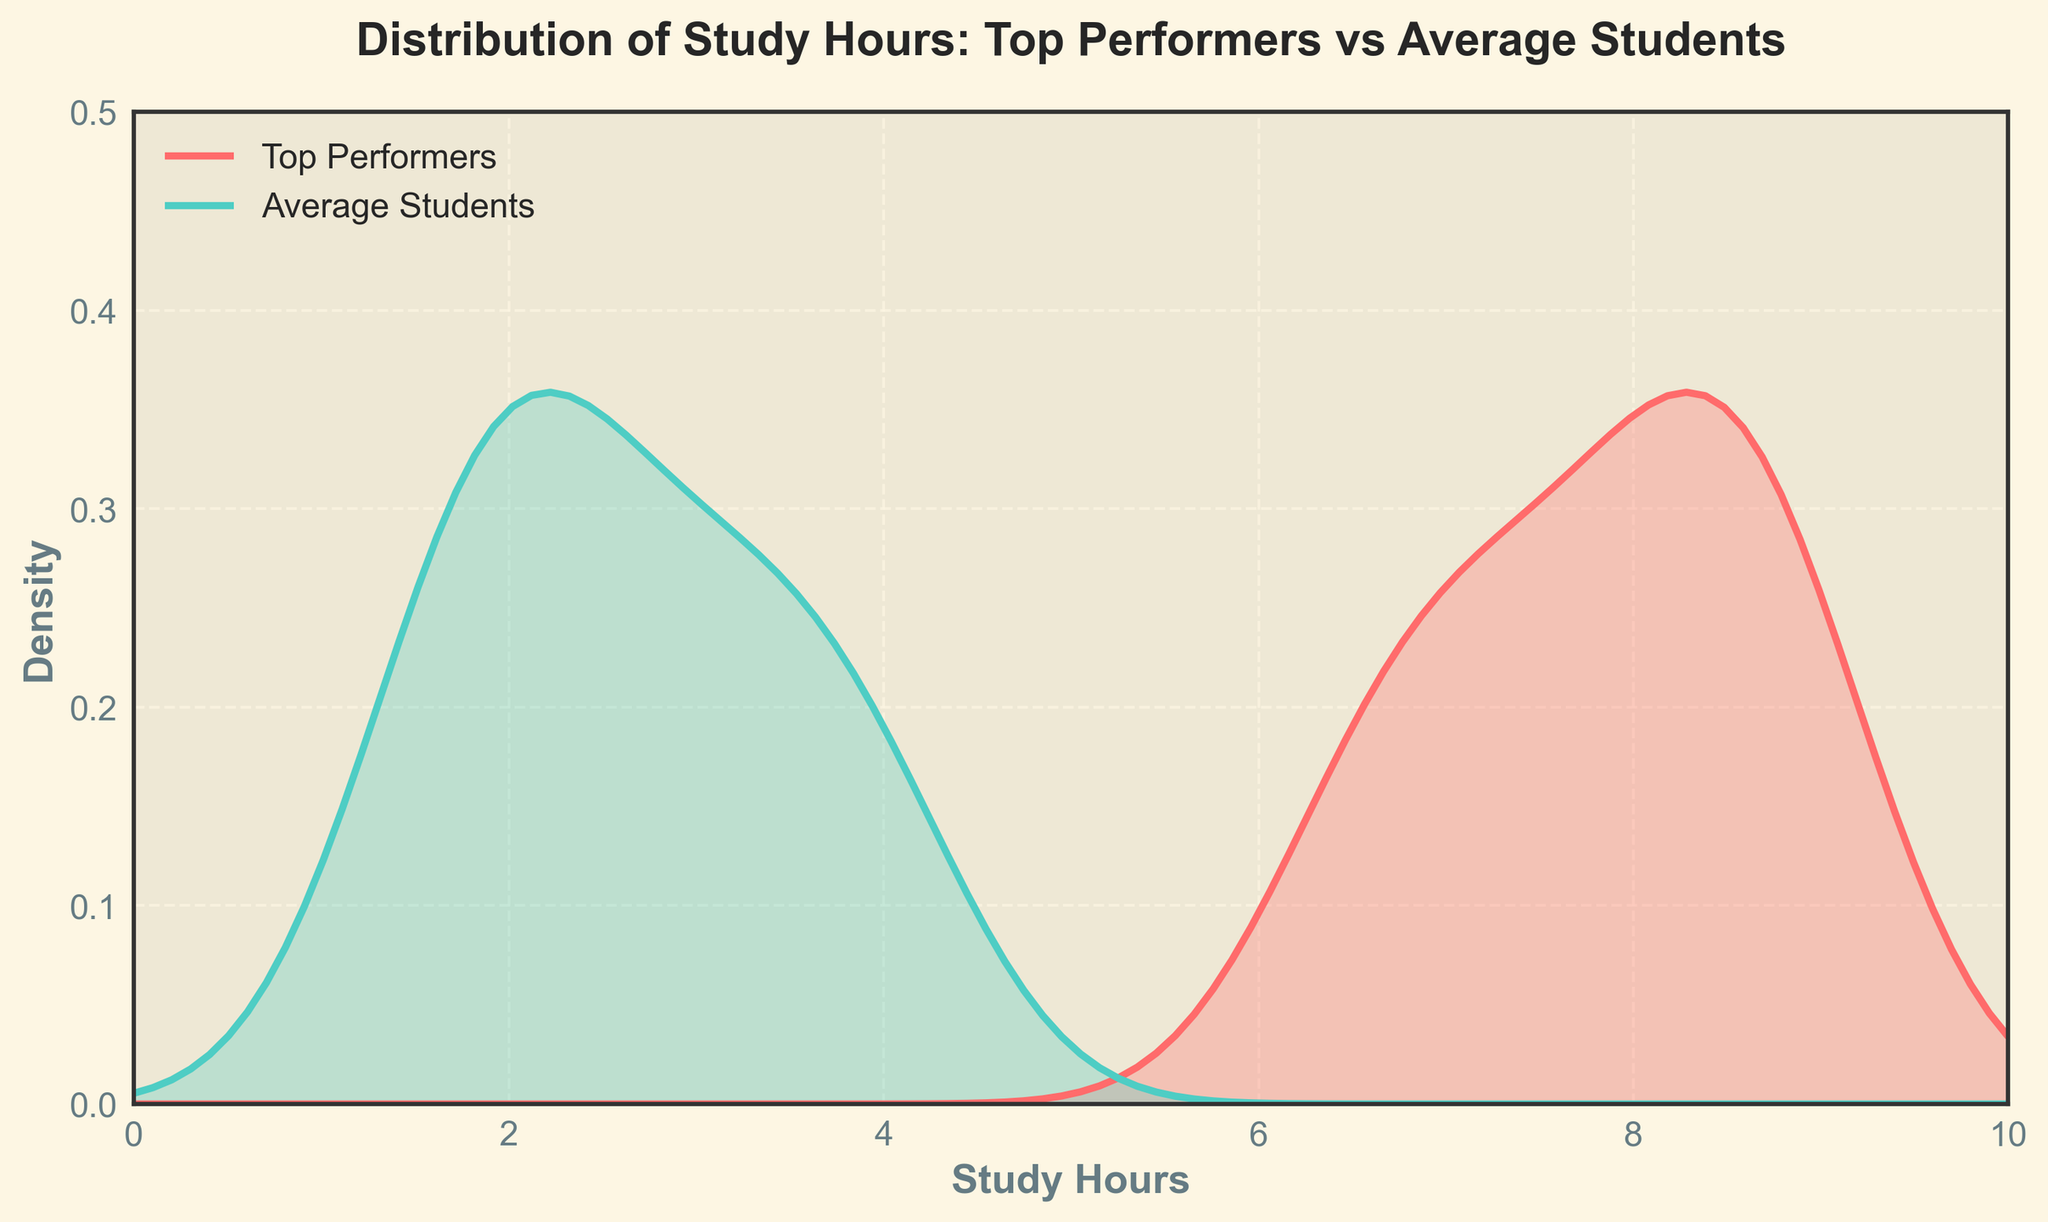What's the title of the plot? The title of the plot is shown at the top of the figure, typically in bold and larger font compared to other text.
Answer: Distribution of Study Hours: Top Performers vs Average Students Which axis represents the study hours? The x-axis represents the study hours, as indicated by the label 'Study Hours' below it.
Answer: x-axis Which color represents the top performers' density plot? The plot uses color coding to distinguish between groups. The top performers' density plot is shown in the color that appears reddish-pink.
Answer: Reddish-pink Where does the density plot for average students peak? The density plot for average students is shown in green. By examining the y-axis values, the peak appears around 2-3 study hours.
Answer: Around 2-3 hours Which group has a broader range of study hours? By comparing the spread of the density plots, the top performers have a broader range since their density curve extends further along the x-axis than the average students'.
Answer: Top performers Can we infer that most top performers study more than average students? The density plot shows that the curve for top performers is shifted to the right, indicating higher study hours compared to average students.
Answer: Yes Do any top performers study less than 5 hours? By examining the density plot for top performers on the left side of the x-axis, there's a minimal density indicating very few top performers study less than 5 hours.
Answer: Very few How does the density of top performers around 7 hours compare to average students? The density of top performers around 7 hours is higher compared to average students, as indicated by the height of the density plot at this point.
Answer: Higher Is there significant overlap between the two curves? The density plots for the two groups overlap slightly in certain regions, particularly around the low and mid study hours, indicating some shared study behaviors.
Answer: Slightly What is the range of study hours where the density of top performers is the highest? By examining the peak of the density curve for top performers, it is highest around 7-9 hours.
Answer: Around 7-9 hours 